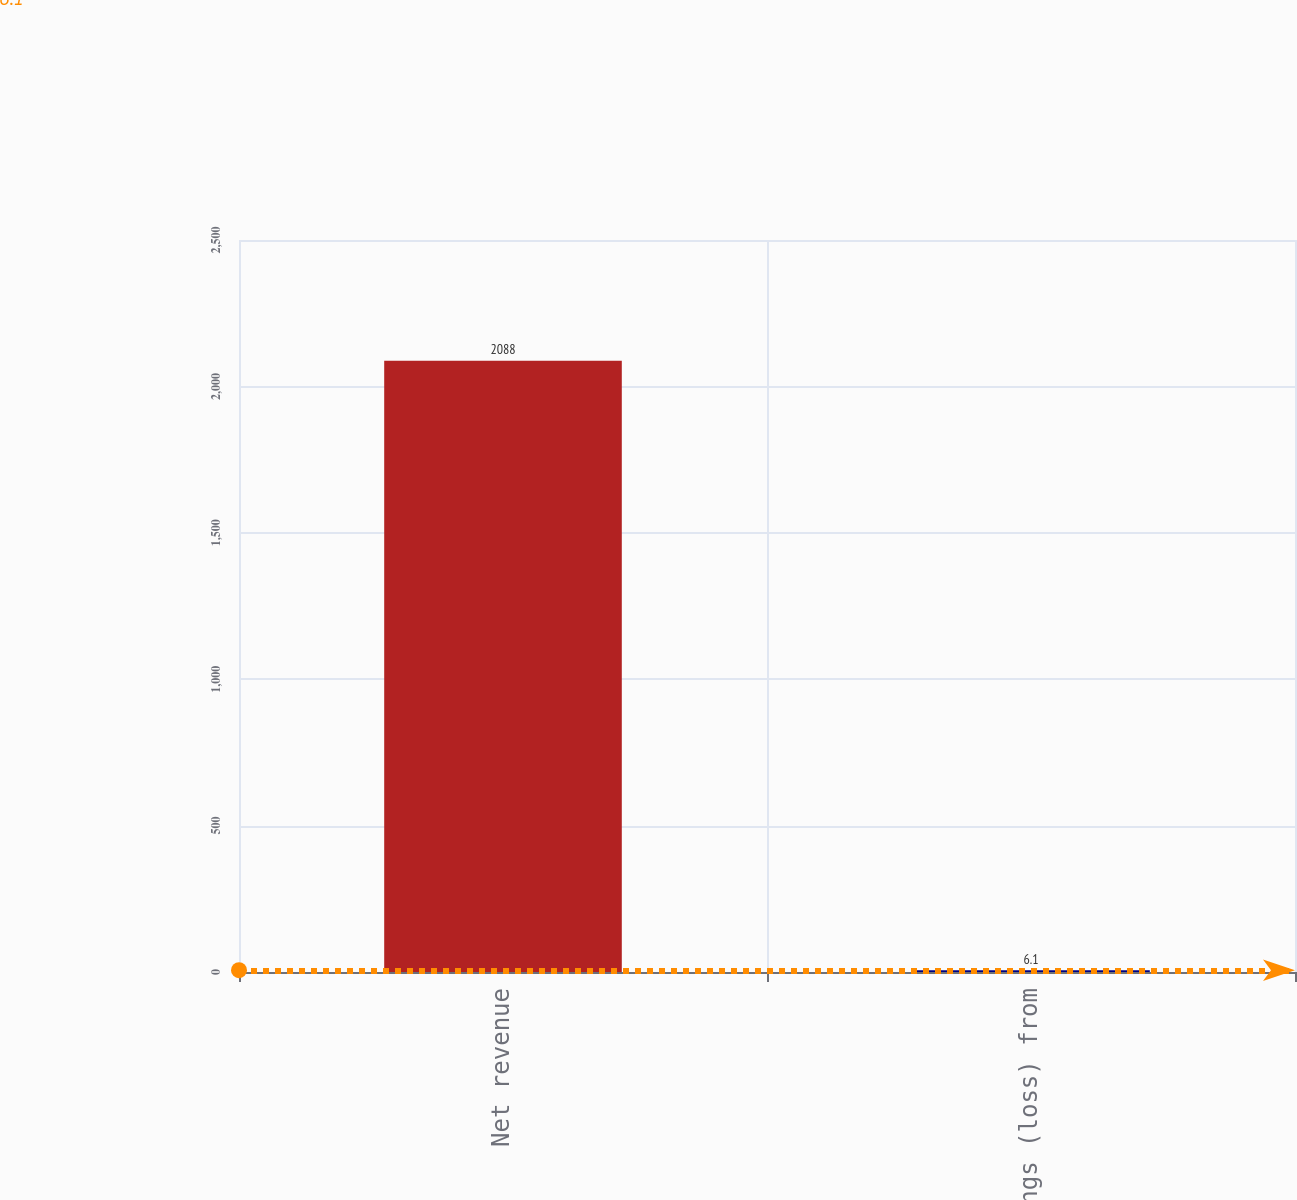<chart> <loc_0><loc_0><loc_500><loc_500><bar_chart><fcel>Net revenue<fcel>Earnings (loss) from<nl><fcel>2088<fcel>6.1<nl></chart> 